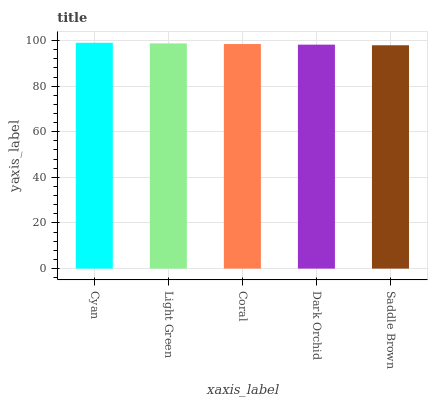Is Saddle Brown the minimum?
Answer yes or no. Yes. Is Cyan the maximum?
Answer yes or no. Yes. Is Light Green the minimum?
Answer yes or no. No. Is Light Green the maximum?
Answer yes or no. No. Is Cyan greater than Light Green?
Answer yes or no. Yes. Is Light Green less than Cyan?
Answer yes or no. Yes. Is Light Green greater than Cyan?
Answer yes or no. No. Is Cyan less than Light Green?
Answer yes or no. No. Is Coral the high median?
Answer yes or no. Yes. Is Coral the low median?
Answer yes or no. Yes. Is Dark Orchid the high median?
Answer yes or no. No. Is Cyan the low median?
Answer yes or no. No. 